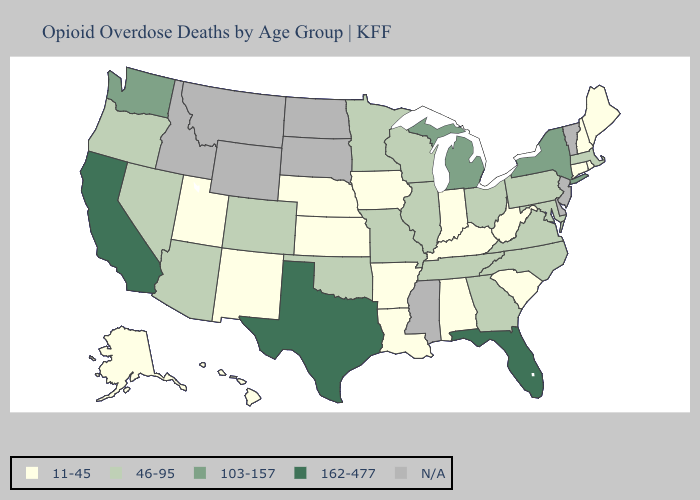What is the highest value in states that border Kansas?
Short answer required. 46-95. Name the states that have a value in the range 103-157?
Write a very short answer. Michigan, New York, Washington. What is the value of South Dakota?
Write a very short answer. N/A. Name the states that have a value in the range 162-477?
Short answer required. California, Florida, Texas. What is the lowest value in the MidWest?
Give a very brief answer. 11-45. What is the highest value in the USA?
Answer briefly. 162-477. What is the lowest value in states that border Nevada?
Write a very short answer. 11-45. Which states have the highest value in the USA?
Give a very brief answer. California, Florida, Texas. What is the lowest value in states that border Rhode Island?
Concise answer only. 11-45. Which states have the lowest value in the USA?
Be succinct. Alabama, Alaska, Arkansas, Connecticut, Hawaii, Indiana, Iowa, Kansas, Kentucky, Louisiana, Maine, Nebraska, New Hampshire, New Mexico, Rhode Island, South Carolina, Utah, West Virginia. What is the value of Connecticut?
Keep it brief. 11-45. What is the highest value in the West ?
Quick response, please. 162-477. What is the lowest value in the West?
Short answer required. 11-45. Name the states that have a value in the range 162-477?
Answer briefly. California, Florida, Texas. 